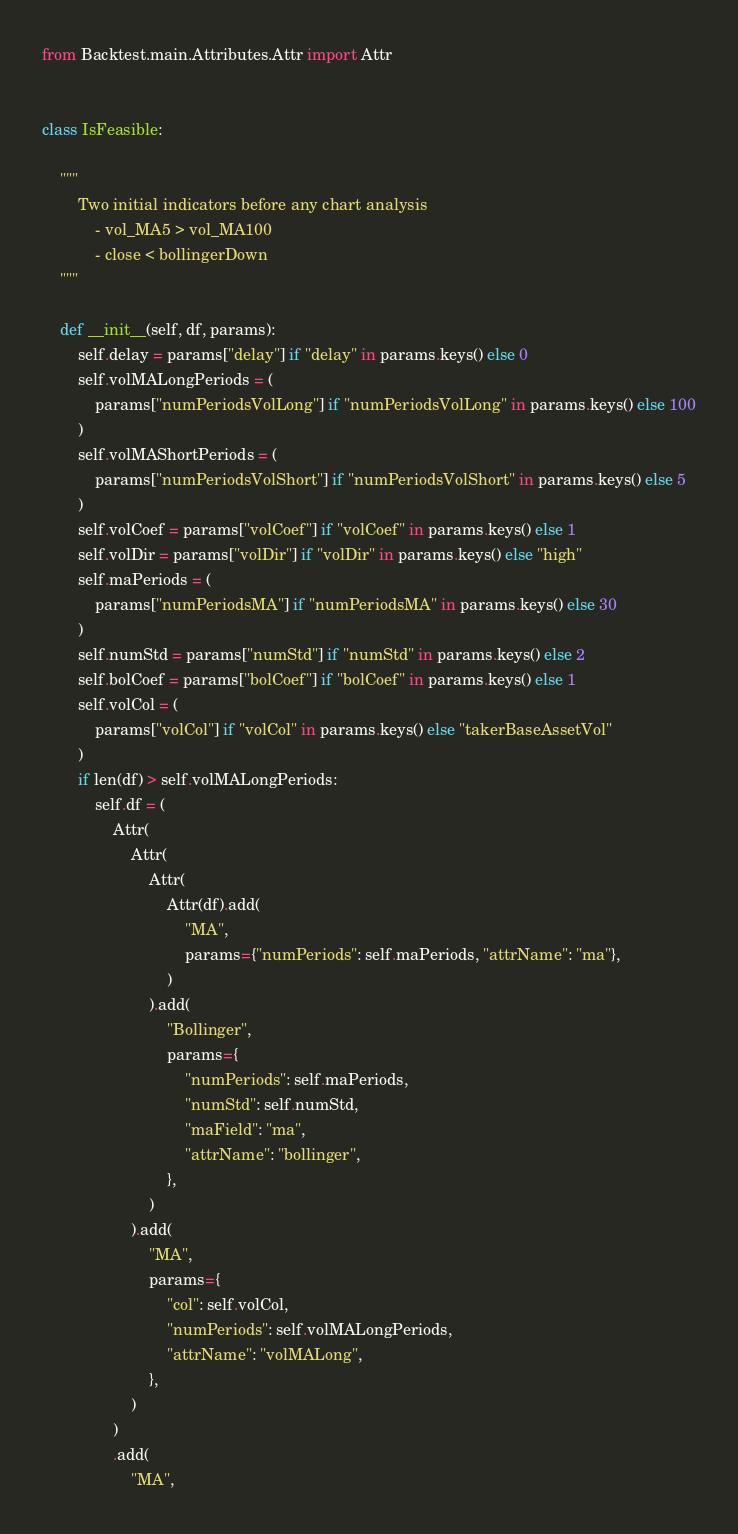Convert code to text. <code><loc_0><loc_0><loc_500><loc_500><_Python_>from Backtest.main.Attributes.Attr import Attr


class IsFeasible:

    """
        Two initial indicators before any chart analysis
            - vol_MA5 > vol_MA100
            - close < bollingerDown
    """

    def __init__(self, df, params):
        self.delay = params["delay"] if "delay" in params.keys() else 0
        self.volMALongPeriods = (
            params["numPeriodsVolLong"] if "numPeriodsVolLong" in params.keys() else 100
        )
        self.volMAShortPeriods = (
            params["numPeriodsVolShort"] if "numPeriodsVolShort" in params.keys() else 5
        )
        self.volCoef = params["volCoef"] if "volCoef" in params.keys() else 1
        self.volDir = params["volDir"] if "volDir" in params.keys() else "high"
        self.maPeriods = (
            params["numPeriodsMA"] if "numPeriodsMA" in params.keys() else 30
        )
        self.numStd = params["numStd"] if "numStd" in params.keys() else 2
        self.bolCoef = params["bolCoef"] if "bolCoef" in params.keys() else 1
        self.volCol = (
            params["volCol"] if "volCol" in params.keys() else "takerBaseAssetVol"
        )
        if len(df) > self.volMALongPeriods:
            self.df = (
                Attr(
                    Attr(
                        Attr(
                            Attr(df).add(
                                "MA",
                                params={"numPeriods": self.maPeriods, "attrName": "ma"},
                            )
                        ).add(
                            "Bollinger",
                            params={
                                "numPeriods": self.maPeriods,
                                "numStd": self.numStd,
                                "maField": "ma",
                                "attrName": "bollinger",
                            },
                        )
                    ).add(
                        "MA",
                        params={
                            "col": self.volCol,
                            "numPeriods": self.volMALongPeriods,
                            "attrName": "volMALong",
                        },
                    )
                )
                .add(
                    "MA",</code> 